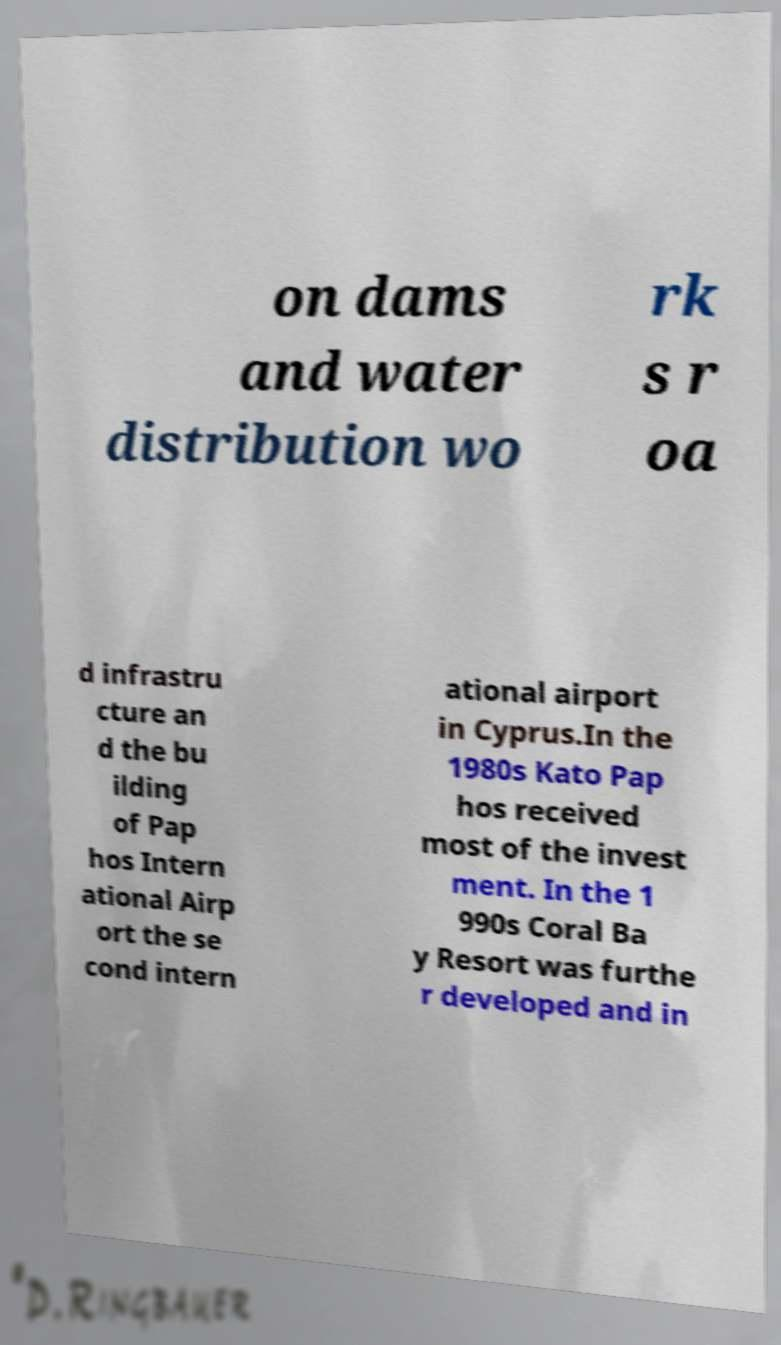Can you read and provide the text displayed in the image?This photo seems to have some interesting text. Can you extract and type it out for me? on dams and water distribution wo rk s r oa d infrastru cture an d the bu ilding of Pap hos Intern ational Airp ort the se cond intern ational airport in Cyprus.In the 1980s Kato Pap hos received most of the invest ment. In the 1 990s Coral Ba y Resort was furthe r developed and in 